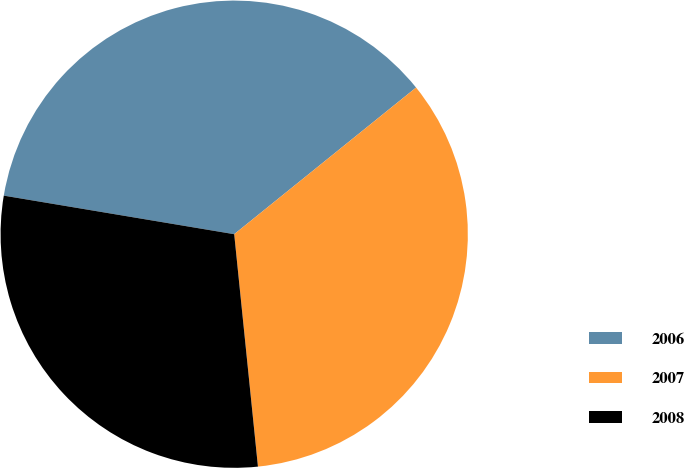Convert chart to OTSL. <chart><loc_0><loc_0><loc_500><loc_500><pie_chart><fcel>2006<fcel>2007<fcel>2008<nl><fcel>36.56%<fcel>34.18%<fcel>29.26%<nl></chart> 